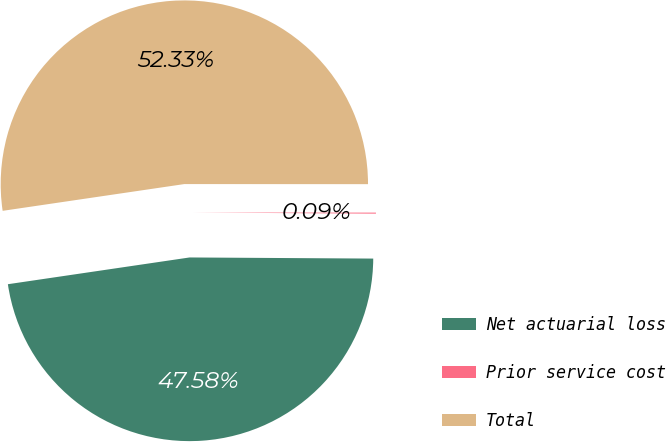Convert chart to OTSL. <chart><loc_0><loc_0><loc_500><loc_500><pie_chart><fcel>Net actuarial loss<fcel>Prior service cost<fcel>Total<nl><fcel>47.58%<fcel>0.09%<fcel>52.34%<nl></chart> 